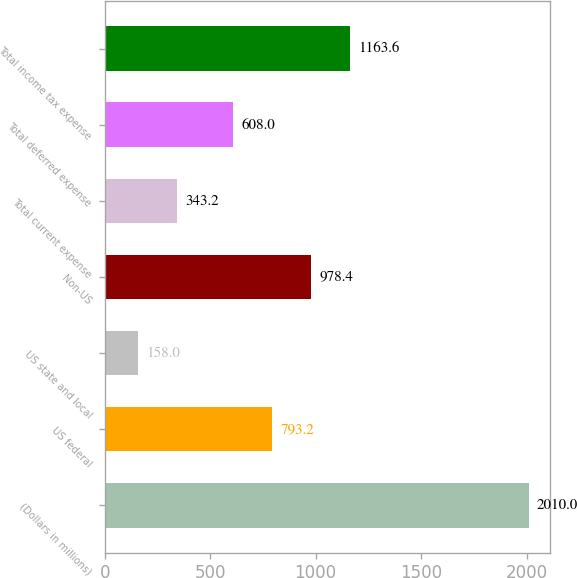Convert chart to OTSL. <chart><loc_0><loc_0><loc_500><loc_500><bar_chart><fcel>(Dollars in millions)<fcel>US federal<fcel>US state and local<fcel>Non-US<fcel>Total current expense<fcel>Total deferred expense<fcel>Total income tax expense<nl><fcel>2010<fcel>793.2<fcel>158<fcel>978.4<fcel>343.2<fcel>608<fcel>1163.6<nl></chart> 